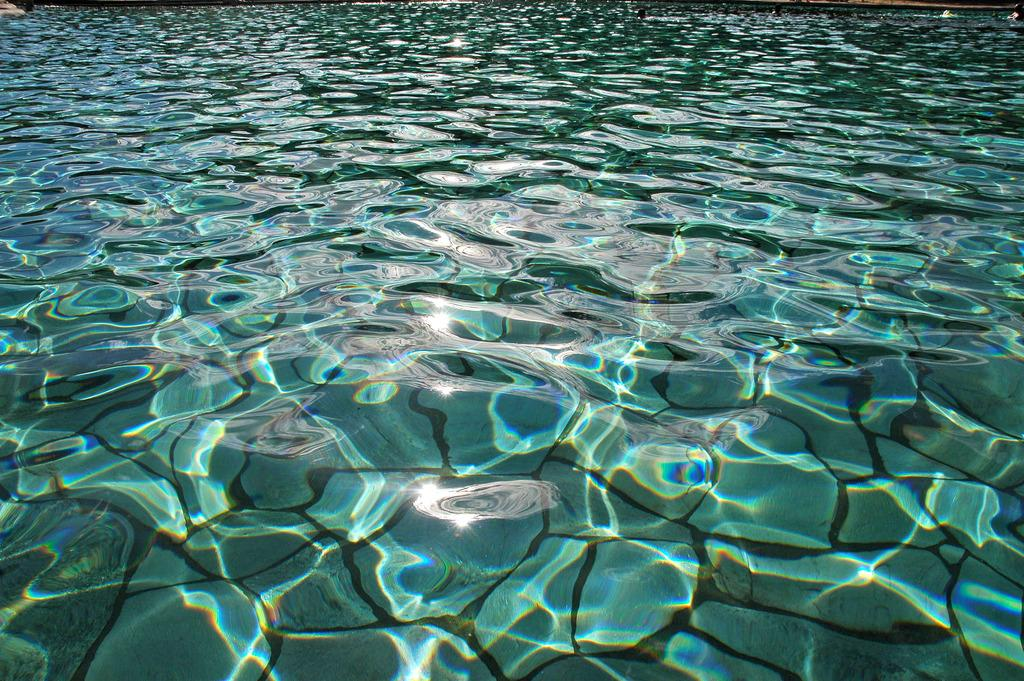What type of objects are present in the image? There are stones in the image. Where are the stones located? The stones are underwater. What type of quill is being used to write on the stones in the image? There is no quill or writing present in the image; it only features stones underwater. 